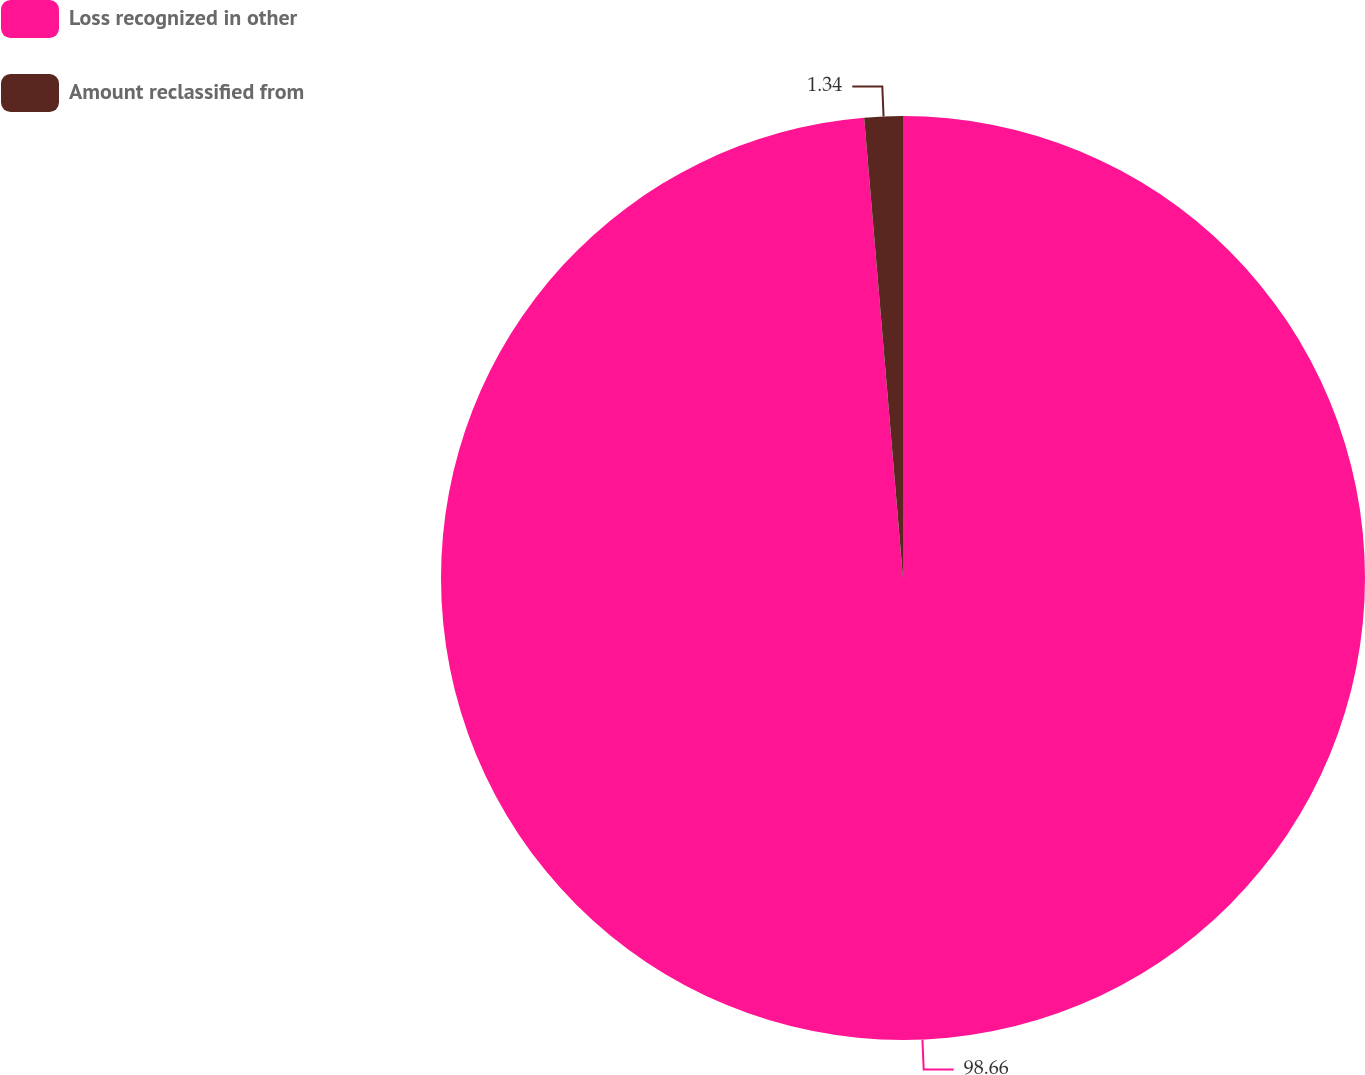<chart> <loc_0><loc_0><loc_500><loc_500><pie_chart><fcel>Loss recognized in other<fcel>Amount reclassified from<nl><fcel>98.66%<fcel>1.34%<nl></chart> 